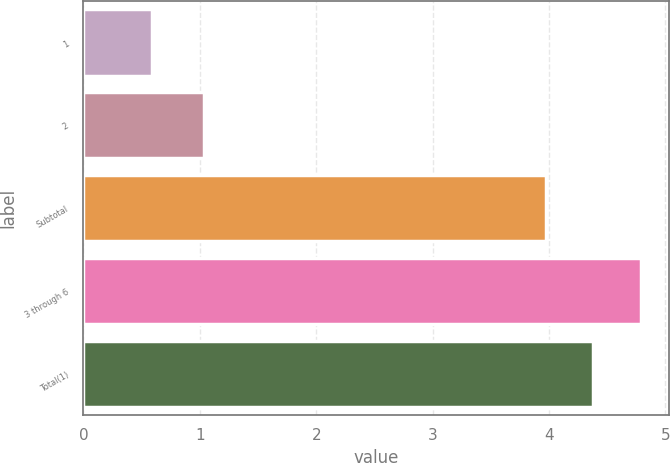Convert chart. <chart><loc_0><loc_0><loc_500><loc_500><bar_chart><fcel>1<fcel>2<fcel>Subtotal<fcel>3 through 6<fcel>Total(1)<nl><fcel>0.59<fcel>1.04<fcel>3.97<fcel>4.79<fcel>4.38<nl></chart> 